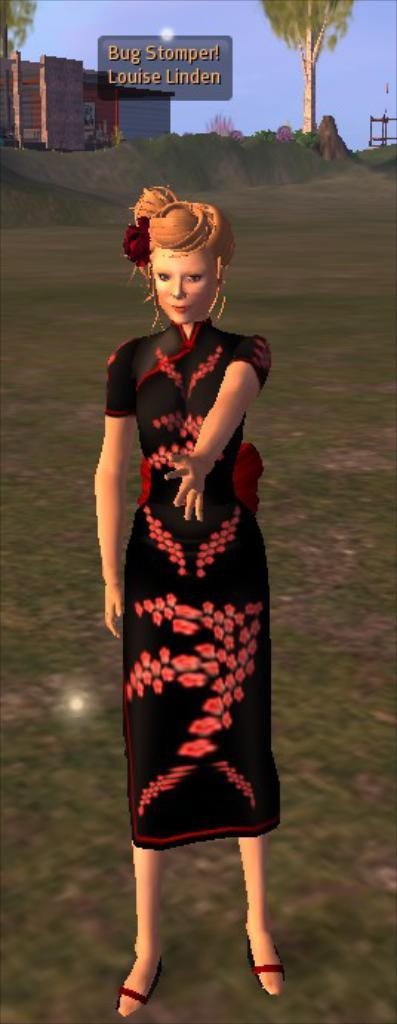What type of image is being described? The image is an animated picture. Who or what can be seen in the image? There is a woman standing in the image. What else is present in the image besides the woman? There are buildings, trees, and the sky visible in the background of the image. How is the image displayed? The image appears to be on a board. What is the value of the gate in the image? There is no gate present in the image, so it is not possible to determine its value. 